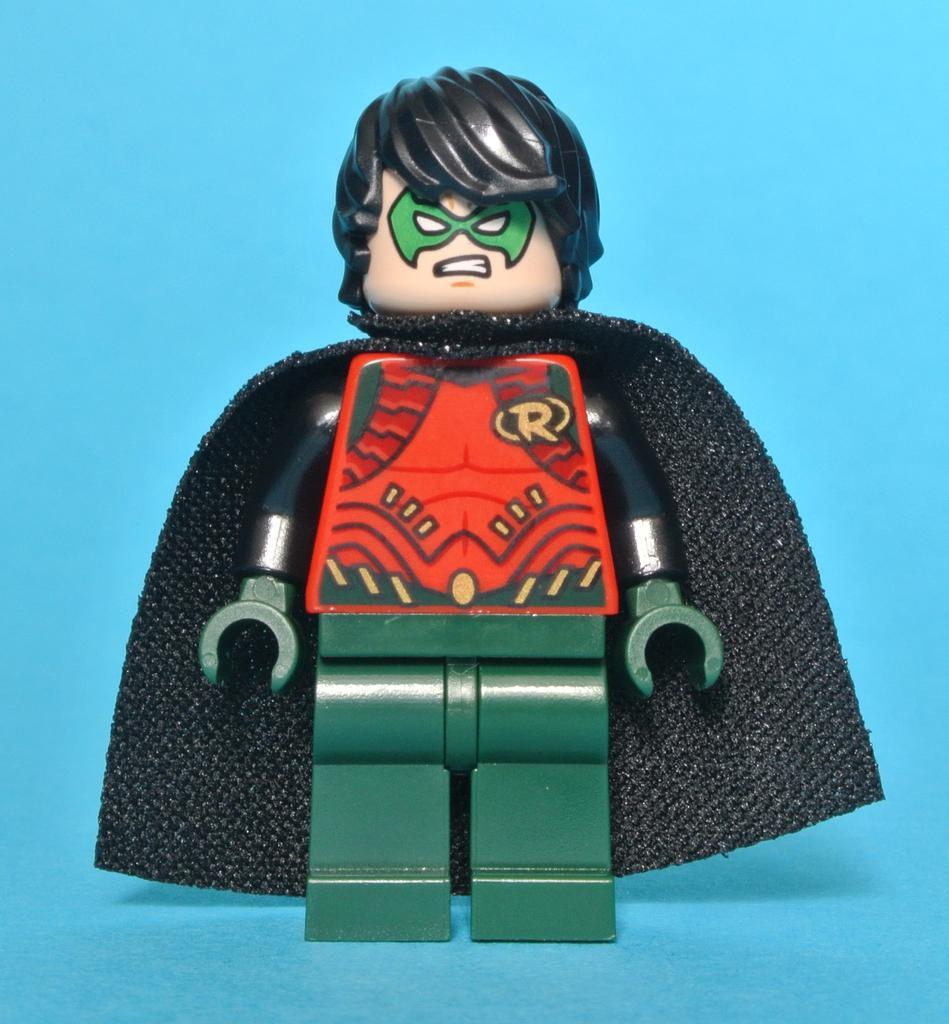Please provide a concise description of this image. In this image I can see a toy which is in black, red and green color. 